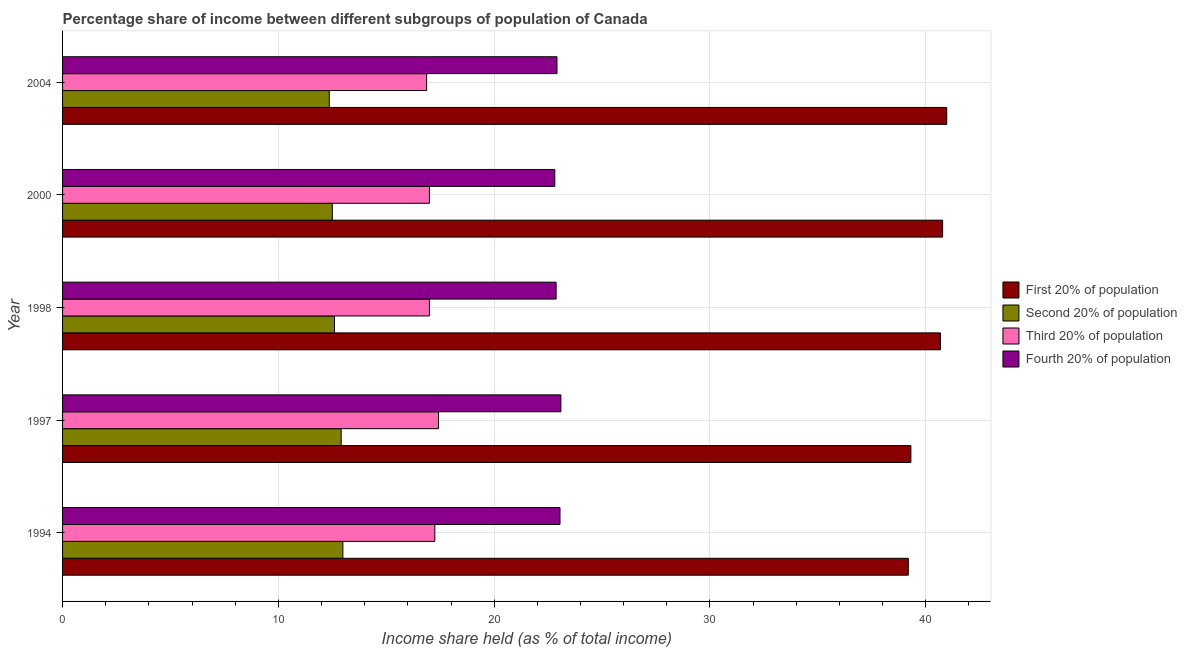How many different coloured bars are there?
Offer a very short reply. 4. Are the number of bars per tick equal to the number of legend labels?
Provide a short and direct response. Yes. Are the number of bars on each tick of the Y-axis equal?
Make the answer very short. Yes. How many bars are there on the 3rd tick from the top?
Provide a short and direct response. 4. What is the share of the income held by first 20% of the population in 1998?
Provide a short and direct response. 40.68. Across all years, what is the maximum share of the income held by fourth 20% of the population?
Your response must be concise. 23.09. Across all years, what is the minimum share of the income held by first 20% of the population?
Provide a succinct answer. 39.19. In which year was the share of the income held by first 20% of the population maximum?
Your response must be concise. 2004. In which year was the share of the income held by second 20% of the population minimum?
Keep it short and to the point. 2004. What is the total share of the income held by first 20% of the population in the graph?
Your response must be concise. 200.93. What is the difference between the share of the income held by third 20% of the population in 2000 and that in 2004?
Offer a very short reply. 0.13. What is the difference between the share of the income held by second 20% of the population in 2000 and the share of the income held by fourth 20% of the population in 1997?
Your response must be concise. -10.59. What is the average share of the income held by third 20% of the population per year?
Offer a terse response. 17.11. In the year 2000, what is the difference between the share of the income held by third 20% of the population and share of the income held by first 20% of the population?
Keep it short and to the point. -23.78. In how many years, is the share of the income held by fourth 20% of the population greater than 36 %?
Offer a terse response. 0. Is the difference between the share of the income held by second 20% of the population in 1997 and 1998 greater than the difference between the share of the income held by first 20% of the population in 1997 and 1998?
Your answer should be very brief. Yes. What is the difference between the highest and the second highest share of the income held by second 20% of the population?
Your answer should be very brief. 0.08. What is the difference between the highest and the lowest share of the income held by first 20% of the population?
Provide a short and direct response. 1.78. In how many years, is the share of the income held by third 20% of the population greater than the average share of the income held by third 20% of the population taken over all years?
Your response must be concise. 2. What does the 1st bar from the top in 2004 represents?
Your answer should be compact. Fourth 20% of population. What does the 4th bar from the bottom in 1997 represents?
Provide a succinct answer. Fourth 20% of population. How many bars are there?
Give a very brief answer. 20. Are all the bars in the graph horizontal?
Your response must be concise. Yes. How many years are there in the graph?
Make the answer very short. 5. What is the difference between two consecutive major ticks on the X-axis?
Your answer should be compact. 10. Does the graph contain any zero values?
Offer a very short reply. No. Does the graph contain grids?
Provide a short and direct response. Yes. Where does the legend appear in the graph?
Offer a very short reply. Center right. How are the legend labels stacked?
Provide a succinct answer. Vertical. What is the title of the graph?
Ensure brevity in your answer.  Percentage share of income between different subgroups of population of Canada. What is the label or title of the X-axis?
Your response must be concise. Income share held (as % of total income). What is the label or title of the Y-axis?
Provide a short and direct response. Year. What is the Income share held (as % of total income) in First 20% of population in 1994?
Give a very brief answer. 39.19. What is the Income share held (as % of total income) in Second 20% of population in 1994?
Give a very brief answer. 12.99. What is the Income share held (as % of total income) of Third 20% of population in 1994?
Your response must be concise. 17.25. What is the Income share held (as % of total income) of Fourth 20% of population in 1994?
Make the answer very short. 23.05. What is the Income share held (as % of total income) in First 20% of population in 1997?
Give a very brief answer. 39.31. What is the Income share held (as % of total income) in Second 20% of population in 1997?
Your answer should be compact. 12.91. What is the Income share held (as % of total income) of Third 20% of population in 1997?
Offer a very short reply. 17.42. What is the Income share held (as % of total income) in Fourth 20% of population in 1997?
Keep it short and to the point. 23.09. What is the Income share held (as % of total income) in First 20% of population in 1998?
Keep it short and to the point. 40.68. What is the Income share held (as % of total income) in Third 20% of population in 1998?
Your answer should be very brief. 17. What is the Income share held (as % of total income) in Fourth 20% of population in 1998?
Your response must be concise. 22.87. What is the Income share held (as % of total income) of First 20% of population in 2000?
Give a very brief answer. 40.78. What is the Income share held (as % of total income) of Second 20% of population in 2000?
Ensure brevity in your answer.  12.5. What is the Income share held (as % of total income) in Fourth 20% of population in 2000?
Give a very brief answer. 22.81. What is the Income share held (as % of total income) in First 20% of population in 2004?
Your answer should be compact. 40.97. What is the Income share held (as % of total income) of Second 20% of population in 2004?
Make the answer very short. 12.36. What is the Income share held (as % of total income) of Third 20% of population in 2004?
Your answer should be very brief. 16.87. What is the Income share held (as % of total income) of Fourth 20% of population in 2004?
Make the answer very short. 22.91. Across all years, what is the maximum Income share held (as % of total income) in First 20% of population?
Give a very brief answer. 40.97. Across all years, what is the maximum Income share held (as % of total income) in Second 20% of population?
Ensure brevity in your answer.  12.99. Across all years, what is the maximum Income share held (as % of total income) in Third 20% of population?
Your response must be concise. 17.42. Across all years, what is the maximum Income share held (as % of total income) in Fourth 20% of population?
Provide a short and direct response. 23.09. Across all years, what is the minimum Income share held (as % of total income) in First 20% of population?
Offer a very short reply. 39.19. Across all years, what is the minimum Income share held (as % of total income) in Second 20% of population?
Provide a succinct answer. 12.36. Across all years, what is the minimum Income share held (as % of total income) in Third 20% of population?
Ensure brevity in your answer.  16.87. Across all years, what is the minimum Income share held (as % of total income) in Fourth 20% of population?
Keep it short and to the point. 22.81. What is the total Income share held (as % of total income) of First 20% of population in the graph?
Provide a succinct answer. 200.93. What is the total Income share held (as % of total income) of Second 20% of population in the graph?
Your response must be concise. 63.36. What is the total Income share held (as % of total income) of Third 20% of population in the graph?
Provide a succinct answer. 85.54. What is the total Income share held (as % of total income) of Fourth 20% of population in the graph?
Your answer should be very brief. 114.73. What is the difference between the Income share held (as % of total income) in First 20% of population in 1994 and that in 1997?
Give a very brief answer. -0.12. What is the difference between the Income share held (as % of total income) in Third 20% of population in 1994 and that in 1997?
Your response must be concise. -0.17. What is the difference between the Income share held (as % of total income) in Fourth 20% of population in 1994 and that in 1997?
Give a very brief answer. -0.04. What is the difference between the Income share held (as % of total income) in First 20% of population in 1994 and that in 1998?
Make the answer very short. -1.49. What is the difference between the Income share held (as % of total income) of Second 20% of population in 1994 and that in 1998?
Make the answer very short. 0.39. What is the difference between the Income share held (as % of total income) of Third 20% of population in 1994 and that in 1998?
Your answer should be very brief. 0.25. What is the difference between the Income share held (as % of total income) in Fourth 20% of population in 1994 and that in 1998?
Provide a succinct answer. 0.18. What is the difference between the Income share held (as % of total income) in First 20% of population in 1994 and that in 2000?
Keep it short and to the point. -1.59. What is the difference between the Income share held (as % of total income) of Second 20% of population in 1994 and that in 2000?
Give a very brief answer. 0.49. What is the difference between the Income share held (as % of total income) in Fourth 20% of population in 1994 and that in 2000?
Make the answer very short. 0.24. What is the difference between the Income share held (as % of total income) of First 20% of population in 1994 and that in 2004?
Ensure brevity in your answer.  -1.78. What is the difference between the Income share held (as % of total income) in Second 20% of population in 1994 and that in 2004?
Offer a terse response. 0.63. What is the difference between the Income share held (as % of total income) of Third 20% of population in 1994 and that in 2004?
Your answer should be compact. 0.38. What is the difference between the Income share held (as % of total income) in Fourth 20% of population in 1994 and that in 2004?
Provide a succinct answer. 0.14. What is the difference between the Income share held (as % of total income) in First 20% of population in 1997 and that in 1998?
Provide a short and direct response. -1.37. What is the difference between the Income share held (as % of total income) in Second 20% of population in 1997 and that in 1998?
Your answer should be very brief. 0.31. What is the difference between the Income share held (as % of total income) in Third 20% of population in 1997 and that in 1998?
Give a very brief answer. 0.42. What is the difference between the Income share held (as % of total income) in Fourth 20% of population in 1997 and that in 1998?
Your response must be concise. 0.22. What is the difference between the Income share held (as % of total income) of First 20% of population in 1997 and that in 2000?
Your answer should be compact. -1.47. What is the difference between the Income share held (as % of total income) of Second 20% of population in 1997 and that in 2000?
Your response must be concise. 0.41. What is the difference between the Income share held (as % of total income) in Third 20% of population in 1997 and that in 2000?
Give a very brief answer. 0.42. What is the difference between the Income share held (as % of total income) in Fourth 20% of population in 1997 and that in 2000?
Your answer should be compact. 0.28. What is the difference between the Income share held (as % of total income) of First 20% of population in 1997 and that in 2004?
Ensure brevity in your answer.  -1.66. What is the difference between the Income share held (as % of total income) in Second 20% of population in 1997 and that in 2004?
Your response must be concise. 0.55. What is the difference between the Income share held (as % of total income) of Third 20% of population in 1997 and that in 2004?
Make the answer very short. 0.55. What is the difference between the Income share held (as % of total income) in Fourth 20% of population in 1997 and that in 2004?
Offer a very short reply. 0.18. What is the difference between the Income share held (as % of total income) of First 20% of population in 1998 and that in 2000?
Your answer should be very brief. -0.1. What is the difference between the Income share held (as % of total income) in Third 20% of population in 1998 and that in 2000?
Your response must be concise. 0. What is the difference between the Income share held (as % of total income) in Fourth 20% of population in 1998 and that in 2000?
Your answer should be very brief. 0.06. What is the difference between the Income share held (as % of total income) of First 20% of population in 1998 and that in 2004?
Make the answer very short. -0.29. What is the difference between the Income share held (as % of total income) of Second 20% of population in 1998 and that in 2004?
Provide a succinct answer. 0.24. What is the difference between the Income share held (as % of total income) in Third 20% of population in 1998 and that in 2004?
Provide a succinct answer. 0.13. What is the difference between the Income share held (as % of total income) of Fourth 20% of population in 1998 and that in 2004?
Provide a succinct answer. -0.04. What is the difference between the Income share held (as % of total income) in First 20% of population in 2000 and that in 2004?
Your response must be concise. -0.19. What is the difference between the Income share held (as % of total income) in Second 20% of population in 2000 and that in 2004?
Your answer should be compact. 0.14. What is the difference between the Income share held (as % of total income) of Third 20% of population in 2000 and that in 2004?
Offer a very short reply. 0.13. What is the difference between the Income share held (as % of total income) of Fourth 20% of population in 2000 and that in 2004?
Offer a very short reply. -0.1. What is the difference between the Income share held (as % of total income) in First 20% of population in 1994 and the Income share held (as % of total income) in Second 20% of population in 1997?
Your answer should be compact. 26.28. What is the difference between the Income share held (as % of total income) of First 20% of population in 1994 and the Income share held (as % of total income) of Third 20% of population in 1997?
Give a very brief answer. 21.77. What is the difference between the Income share held (as % of total income) in Second 20% of population in 1994 and the Income share held (as % of total income) in Third 20% of population in 1997?
Give a very brief answer. -4.43. What is the difference between the Income share held (as % of total income) of Second 20% of population in 1994 and the Income share held (as % of total income) of Fourth 20% of population in 1997?
Your answer should be very brief. -10.1. What is the difference between the Income share held (as % of total income) of Third 20% of population in 1994 and the Income share held (as % of total income) of Fourth 20% of population in 1997?
Give a very brief answer. -5.84. What is the difference between the Income share held (as % of total income) in First 20% of population in 1994 and the Income share held (as % of total income) in Second 20% of population in 1998?
Provide a succinct answer. 26.59. What is the difference between the Income share held (as % of total income) in First 20% of population in 1994 and the Income share held (as % of total income) in Third 20% of population in 1998?
Give a very brief answer. 22.19. What is the difference between the Income share held (as % of total income) of First 20% of population in 1994 and the Income share held (as % of total income) of Fourth 20% of population in 1998?
Offer a terse response. 16.32. What is the difference between the Income share held (as % of total income) in Second 20% of population in 1994 and the Income share held (as % of total income) in Third 20% of population in 1998?
Keep it short and to the point. -4.01. What is the difference between the Income share held (as % of total income) in Second 20% of population in 1994 and the Income share held (as % of total income) in Fourth 20% of population in 1998?
Offer a very short reply. -9.88. What is the difference between the Income share held (as % of total income) in Third 20% of population in 1994 and the Income share held (as % of total income) in Fourth 20% of population in 1998?
Provide a succinct answer. -5.62. What is the difference between the Income share held (as % of total income) of First 20% of population in 1994 and the Income share held (as % of total income) of Second 20% of population in 2000?
Offer a very short reply. 26.69. What is the difference between the Income share held (as % of total income) in First 20% of population in 1994 and the Income share held (as % of total income) in Third 20% of population in 2000?
Offer a very short reply. 22.19. What is the difference between the Income share held (as % of total income) of First 20% of population in 1994 and the Income share held (as % of total income) of Fourth 20% of population in 2000?
Provide a short and direct response. 16.38. What is the difference between the Income share held (as % of total income) in Second 20% of population in 1994 and the Income share held (as % of total income) in Third 20% of population in 2000?
Provide a succinct answer. -4.01. What is the difference between the Income share held (as % of total income) in Second 20% of population in 1994 and the Income share held (as % of total income) in Fourth 20% of population in 2000?
Your answer should be compact. -9.82. What is the difference between the Income share held (as % of total income) of Third 20% of population in 1994 and the Income share held (as % of total income) of Fourth 20% of population in 2000?
Give a very brief answer. -5.56. What is the difference between the Income share held (as % of total income) of First 20% of population in 1994 and the Income share held (as % of total income) of Second 20% of population in 2004?
Offer a terse response. 26.83. What is the difference between the Income share held (as % of total income) of First 20% of population in 1994 and the Income share held (as % of total income) of Third 20% of population in 2004?
Your answer should be very brief. 22.32. What is the difference between the Income share held (as % of total income) of First 20% of population in 1994 and the Income share held (as % of total income) of Fourth 20% of population in 2004?
Offer a terse response. 16.28. What is the difference between the Income share held (as % of total income) of Second 20% of population in 1994 and the Income share held (as % of total income) of Third 20% of population in 2004?
Your answer should be compact. -3.88. What is the difference between the Income share held (as % of total income) in Second 20% of population in 1994 and the Income share held (as % of total income) in Fourth 20% of population in 2004?
Make the answer very short. -9.92. What is the difference between the Income share held (as % of total income) of Third 20% of population in 1994 and the Income share held (as % of total income) of Fourth 20% of population in 2004?
Make the answer very short. -5.66. What is the difference between the Income share held (as % of total income) of First 20% of population in 1997 and the Income share held (as % of total income) of Second 20% of population in 1998?
Ensure brevity in your answer.  26.71. What is the difference between the Income share held (as % of total income) of First 20% of population in 1997 and the Income share held (as % of total income) of Third 20% of population in 1998?
Your answer should be compact. 22.31. What is the difference between the Income share held (as % of total income) in First 20% of population in 1997 and the Income share held (as % of total income) in Fourth 20% of population in 1998?
Give a very brief answer. 16.44. What is the difference between the Income share held (as % of total income) of Second 20% of population in 1997 and the Income share held (as % of total income) of Third 20% of population in 1998?
Your answer should be very brief. -4.09. What is the difference between the Income share held (as % of total income) of Second 20% of population in 1997 and the Income share held (as % of total income) of Fourth 20% of population in 1998?
Your response must be concise. -9.96. What is the difference between the Income share held (as % of total income) of Third 20% of population in 1997 and the Income share held (as % of total income) of Fourth 20% of population in 1998?
Your response must be concise. -5.45. What is the difference between the Income share held (as % of total income) of First 20% of population in 1997 and the Income share held (as % of total income) of Second 20% of population in 2000?
Provide a short and direct response. 26.81. What is the difference between the Income share held (as % of total income) in First 20% of population in 1997 and the Income share held (as % of total income) in Third 20% of population in 2000?
Make the answer very short. 22.31. What is the difference between the Income share held (as % of total income) in First 20% of population in 1997 and the Income share held (as % of total income) in Fourth 20% of population in 2000?
Provide a short and direct response. 16.5. What is the difference between the Income share held (as % of total income) in Second 20% of population in 1997 and the Income share held (as % of total income) in Third 20% of population in 2000?
Give a very brief answer. -4.09. What is the difference between the Income share held (as % of total income) in Third 20% of population in 1997 and the Income share held (as % of total income) in Fourth 20% of population in 2000?
Offer a very short reply. -5.39. What is the difference between the Income share held (as % of total income) of First 20% of population in 1997 and the Income share held (as % of total income) of Second 20% of population in 2004?
Provide a short and direct response. 26.95. What is the difference between the Income share held (as % of total income) of First 20% of population in 1997 and the Income share held (as % of total income) of Third 20% of population in 2004?
Provide a succinct answer. 22.44. What is the difference between the Income share held (as % of total income) of Second 20% of population in 1997 and the Income share held (as % of total income) of Third 20% of population in 2004?
Ensure brevity in your answer.  -3.96. What is the difference between the Income share held (as % of total income) of Second 20% of population in 1997 and the Income share held (as % of total income) of Fourth 20% of population in 2004?
Keep it short and to the point. -10. What is the difference between the Income share held (as % of total income) in Third 20% of population in 1997 and the Income share held (as % of total income) in Fourth 20% of population in 2004?
Your response must be concise. -5.49. What is the difference between the Income share held (as % of total income) of First 20% of population in 1998 and the Income share held (as % of total income) of Second 20% of population in 2000?
Make the answer very short. 28.18. What is the difference between the Income share held (as % of total income) of First 20% of population in 1998 and the Income share held (as % of total income) of Third 20% of population in 2000?
Your answer should be very brief. 23.68. What is the difference between the Income share held (as % of total income) of First 20% of population in 1998 and the Income share held (as % of total income) of Fourth 20% of population in 2000?
Provide a succinct answer. 17.87. What is the difference between the Income share held (as % of total income) in Second 20% of population in 1998 and the Income share held (as % of total income) in Third 20% of population in 2000?
Ensure brevity in your answer.  -4.4. What is the difference between the Income share held (as % of total income) of Second 20% of population in 1998 and the Income share held (as % of total income) of Fourth 20% of population in 2000?
Provide a short and direct response. -10.21. What is the difference between the Income share held (as % of total income) of Third 20% of population in 1998 and the Income share held (as % of total income) of Fourth 20% of population in 2000?
Offer a terse response. -5.81. What is the difference between the Income share held (as % of total income) of First 20% of population in 1998 and the Income share held (as % of total income) of Second 20% of population in 2004?
Keep it short and to the point. 28.32. What is the difference between the Income share held (as % of total income) in First 20% of population in 1998 and the Income share held (as % of total income) in Third 20% of population in 2004?
Your answer should be very brief. 23.81. What is the difference between the Income share held (as % of total income) in First 20% of population in 1998 and the Income share held (as % of total income) in Fourth 20% of population in 2004?
Ensure brevity in your answer.  17.77. What is the difference between the Income share held (as % of total income) of Second 20% of population in 1998 and the Income share held (as % of total income) of Third 20% of population in 2004?
Keep it short and to the point. -4.27. What is the difference between the Income share held (as % of total income) of Second 20% of population in 1998 and the Income share held (as % of total income) of Fourth 20% of population in 2004?
Provide a short and direct response. -10.31. What is the difference between the Income share held (as % of total income) of Third 20% of population in 1998 and the Income share held (as % of total income) of Fourth 20% of population in 2004?
Offer a very short reply. -5.91. What is the difference between the Income share held (as % of total income) of First 20% of population in 2000 and the Income share held (as % of total income) of Second 20% of population in 2004?
Give a very brief answer. 28.42. What is the difference between the Income share held (as % of total income) of First 20% of population in 2000 and the Income share held (as % of total income) of Third 20% of population in 2004?
Give a very brief answer. 23.91. What is the difference between the Income share held (as % of total income) of First 20% of population in 2000 and the Income share held (as % of total income) of Fourth 20% of population in 2004?
Provide a short and direct response. 17.87. What is the difference between the Income share held (as % of total income) of Second 20% of population in 2000 and the Income share held (as % of total income) of Third 20% of population in 2004?
Provide a succinct answer. -4.37. What is the difference between the Income share held (as % of total income) in Second 20% of population in 2000 and the Income share held (as % of total income) in Fourth 20% of population in 2004?
Offer a terse response. -10.41. What is the difference between the Income share held (as % of total income) of Third 20% of population in 2000 and the Income share held (as % of total income) of Fourth 20% of population in 2004?
Provide a succinct answer. -5.91. What is the average Income share held (as % of total income) of First 20% of population per year?
Provide a succinct answer. 40.19. What is the average Income share held (as % of total income) of Second 20% of population per year?
Your answer should be very brief. 12.67. What is the average Income share held (as % of total income) in Third 20% of population per year?
Offer a very short reply. 17.11. What is the average Income share held (as % of total income) of Fourth 20% of population per year?
Make the answer very short. 22.95. In the year 1994, what is the difference between the Income share held (as % of total income) of First 20% of population and Income share held (as % of total income) of Second 20% of population?
Offer a very short reply. 26.2. In the year 1994, what is the difference between the Income share held (as % of total income) of First 20% of population and Income share held (as % of total income) of Third 20% of population?
Your answer should be very brief. 21.94. In the year 1994, what is the difference between the Income share held (as % of total income) in First 20% of population and Income share held (as % of total income) in Fourth 20% of population?
Your response must be concise. 16.14. In the year 1994, what is the difference between the Income share held (as % of total income) in Second 20% of population and Income share held (as % of total income) in Third 20% of population?
Provide a succinct answer. -4.26. In the year 1994, what is the difference between the Income share held (as % of total income) of Second 20% of population and Income share held (as % of total income) of Fourth 20% of population?
Your answer should be compact. -10.06. In the year 1997, what is the difference between the Income share held (as % of total income) in First 20% of population and Income share held (as % of total income) in Second 20% of population?
Offer a terse response. 26.4. In the year 1997, what is the difference between the Income share held (as % of total income) in First 20% of population and Income share held (as % of total income) in Third 20% of population?
Provide a short and direct response. 21.89. In the year 1997, what is the difference between the Income share held (as % of total income) of First 20% of population and Income share held (as % of total income) of Fourth 20% of population?
Make the answer very short. 16.22. In the year 1997, what is the difference between the Income share held (as % of total income) in Second 20% of population and Income share held (as % of total income) in Third 20% of population?
Offer a terse response. -4.51. In the year 1997, what is the difference between the Income share held (as % of total income) of Second 20% of population and Income share held (as % of total income) of Fourth 20% of population?
Give a very brief answer. -10.18. In the year 1997, what is the difference between the Income share held (as % of total income) in Third 20% of population and Income share held (as % of total income) in Fourth 20% of population?
Provide a short and direct response. -5.67. In the year 1998, what is the difference between the Income share held (as % of total income) of First 20% of population and Income share held (as % of total income) of Second 20% of population?
Offer a very short reply. 28.08. In the year 1998, what is the difference between the Income share held (as % of total income) of First 20% of population and Income share held (as % of total income) of Third 20% of population?
Provide a succinct answer. 23.68. In the year 1998, what is the difference between the Income share held (as % of total income) in First 20% of population and Income share held (as % of total income) in Fourth 20% of population?
Make the answer very short. 17.81. In the year 1998, what is the difference between the Income share held (as % of total income) of Second 20% of population and Income share held (as % of total income) of Third 20% of population?
Your answer should be compact. -4.4. In the year 1998, what is the difference between the Income share held (as % of total income) in Second 20% of population and Income share held (as % of total income) in Fourth 20% of population?
Provide a succinct answer. -10.27. In the year 1998, what is the difference between the Income share held (as % of total income) of Third 20% of population and Income share held (as % of total income) of Fourth 20% of population?
Your answer should be compact. -5.87. In the year 2000, what is the difference between the Income share held (as % of total income) of First 20% of population and Income share held (as % of total income) of Second 20% of population?
Offer a terse response. 28.28. In the year 2000, what is the difference between the Income share held (as % of total income) in First 20% of population and Income share held (as % of total income) in Third 20% of population?
Your answer should be compact. 23.78. In the year 2000, what is the difference between the Income share held (as % of total income) in First 20% of population and Income share held (as % of total income) in Fourth 20% of population?
Give a very brief answer. 17.97. In the year 2000, what is the difference between the Income share held (as % of total income) of Second 20% of population and Income share held (as % of total income) of Fourth 20% of population?
Ensure brevity in your answer.  -10.31. In the year 2000, what is the difference between the Income share held (as % of total income) in Third 20% of population and Income share held (as % of total income) in Fourth 20% of population?
Keep it short and to the point. -5.81. In the year 2004, what is the difference between the Income share held (as % of total income) of First 20% of population and Income share held (as % of total income) of Second 20% of population?
Your response must be concise. 28.61. In the year 2004, what is the difference between the Income share held (as % of total income) in First 20% of population and Income share held (as % of total income) in Third 20% of population?
Your answer should be very brief. 24.1. In the year 2004, what is the difference between the Income share held (as % of total income) of First 20% of population and Income share held (as % of total income) of Fourth 20% of population?
Give a very brief answer. 18.06. In the year 2004, what is the difference between the Income share held (as % of total income) in Second 20% of population and Income share held (as % of total income) in Third 20% of population?
Keep it short and to the point. -4.51. In the year 2004, what is the difference between the Income share held (as % of total income) in Second 20% of population and Income share held (as % of total income) in Fourth 20% of population?
Offer a very short reply. -10.55. In the year 2004, what is the difference between the Income share held (as % of total income) of Third 20% of population and Income share held (as % of total income) of Fourth 20% of population?
Provide a succinct answer. -6.04. What is the ratio of the Income share held (as % of total income) of Third 20% of population in 1994 to that in 1997?
Provide a succinct answer. 0.99. What is the ratio of the Income share held (as % of total income) in First 20% of population in 1994 to that in 1998?
Provide a short and direct response. 0.96. What is the ratio of the Income share held (as % of total income) of Second 20% of population in 1994 to that in 1998?
Provide a succinct answer. 1.03. What is the ratio of the Income share held (as % of total income) of Third 20% of population in 1994 to that in 1998?
Ensure brevity in your answer.  1.01. What is the ratio of the Income share held (as % of total income) of Fourth 20% of population in 1994 to that in 1998?
Offer a terse response. 1.01. What is the ratio of the Income share held (as % of total income) of First 20% of population in 1994 to that in 2000?
Make the answer very short. 0.96. What is the ratio of the Income share held (as % of total income) of Second 20% of population in 1994 to that in 2000?
Make the answer very short. 1.04. What is the ratio of the Income share held (as % of total income) in Third 20% of population in 1994 to that in 2000?
Your response must be concise. 1.01. What is the ratio of the Income share held (as % of total income) in Fourth 20% of population in 1994 to that in 2000?
Make the answer very short. 1.01. What is the ratio of the Income share held (as % of total income) in First 20% of population in 1994 to that in 2004?
Your response must be concise. 0.96. What is the ratio of the Income share held (as % of total income) in Second 20% of population in 1994 to that in 2004?
Your answer should be very brief. 1.05. What is the ratio of the Income share held (as % of total income) of Third 20% of population in 1994 to that in 2004?
Your answer should be compact. 1.02. What is the ratio of the Income share held (as % of total income) in Fourth 20% of population in 1994 to that in 2004?
Offer a very short reply. 1.01. What is the ratio of the Income share held (as % of total income) in First 20% of population in 1997 to that in 1998?
Give a very brief answer. 0.97. What is the ratio of the Income share held (as % of total income) of Second 20% of population in 1997 to that in 1998?
Ensure brevity in your answer.  1.02. What is the ratio of the Income share held (as % of total income) in Third 20% of population in 1997 to that in 1998?
Keep it short and to the point. 1.02. What is the ratio of the Income share held (as % of total income) of Fourth 20% of population in 1997 to that in 1998?
Give a very brief answer. 1.01. What is the ratio of the Income share held (as % of total income) in Second 20% of population in 1997 to that in 2000?
Keep it short and to the point. 1.03. What is the ratio of the Income share held (as % of total income) in Third 20% of population in 1997 to that in 2000?
Give a very brief answer. 1.02. What is the ratio of the Income share held (as % of total income) in Fourth 20% of population in 1997 to that in 2000?
Offer a terse response. 1.01. What is the ratio of the Income share held (as % of total income) of First 20% of population in 1997 to that in 2004?
Your response must be concise. 0.96. What is the ratio of the Income share held (as % of total income) in Second 20% of population in 1997 to that in 2004?
Your answer should be compact. 1.04. What is the ratio of the Income share held (as % of total income) of Third 20% of population in 1997 to that in 2004?
Ensure brevity in your answer.  1.03. What is the ratio of the Income share held (as % of total income) in Fourth 20% of population in 1997 to that in 2004?
Your response must be concise. 1.01. What is the ratio of the Income share held (as % of total income) of Second 20% of population in 1998 to that in 2004?
Make the answer very short. 1.02. What is the ratio of the Income share held (as % of total income) of Third 20% of population in 1998 to that in 2004?
Keep it short and to the point. 1.01. What is the ratio of the Income share held (as % of total income) in Fourth 20% of population in 1998 to that in 2004?
Offer a very short reply. 1. What is the ratio of the Income share held (as % of total income) in First 20% of population in 2000 to that in 2004?
Your answer should be very brief. 1. What is the ratio of the Income share held (as % of total income) in Second 20% of population in 2000 to that in 2004?
Offer a very short reply. 1.01. What is the ratio of the Income share held (as % of total income) in Third 20% of population in 2000 to that in 2004?
Offer a very short reply. 1.01. What is the ratio of the Income share held (as % of total income) of Fourth 20% of population in 2000 to that in 2004?
Offer a terse response. 1. What is the difference between the highest and the second highest Income share held (as % of total income) in First 20% of population?
Ensure brevity in your answer.  0.19. What is the difference between the highest and the second highest Income share held (as % of total income) in Second 20% of population?
Make the answer very short. 0.08. What is the difference between the highest and the second highest Income share held (as % of total income) in Third 20% of population?
Give a very brief answer. 0.17. What is the difference between the highest and the lowest Income share held (as % of total income) in First 20% of population?
Your response must be concise. 1.78. What is the difference between the highest and the lowest Income share held (as % of total income) in Second 20% of population?
Provide a short and direct response. 0.63. What is the difference between the highest and the lowest Income share held (as % of total income) in Third 20% of population?
Make the answer very short. 0.55. What is the difference between the highest and the lowest Income share held (as % of total income) of Fourth 20% of population?
Provide a short and direct response. 0.28. 